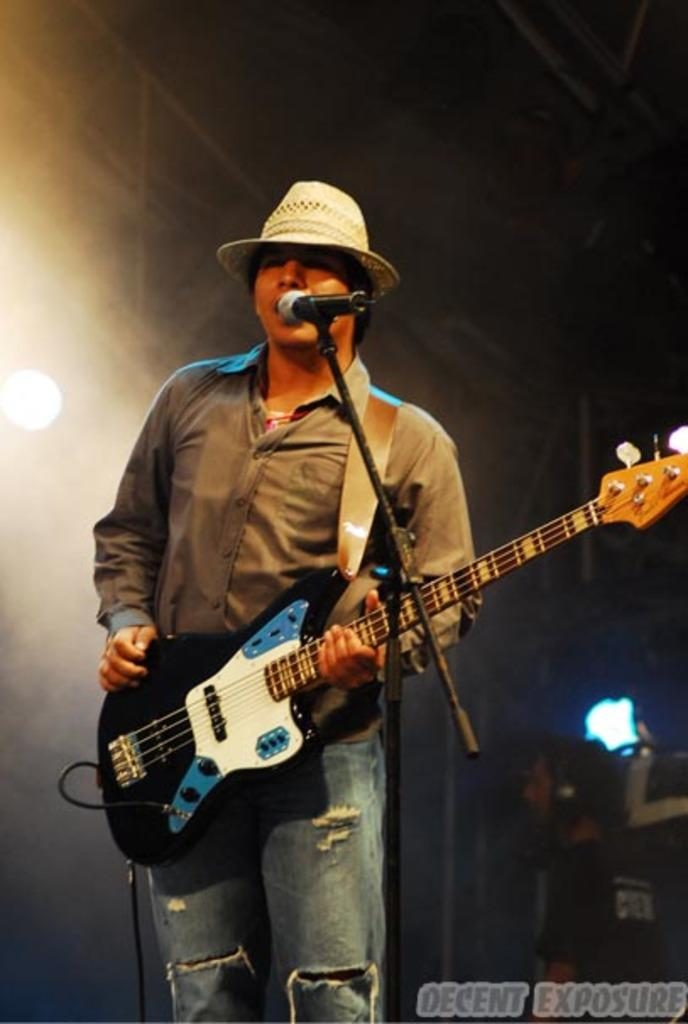What is the main subject of the image? There is a person standing in the image. What is the person doing in the image? The person is playing a guitar. Can you describe the person's attire? The person is wearing a cap. Are there any other people in the image? Yes, there is a person sitting on the right side of the image. How many lizards can be seen crawling on the guitar in the image? There are no lizards present in the image, and therefore none can be seen crawling on the guitar. 